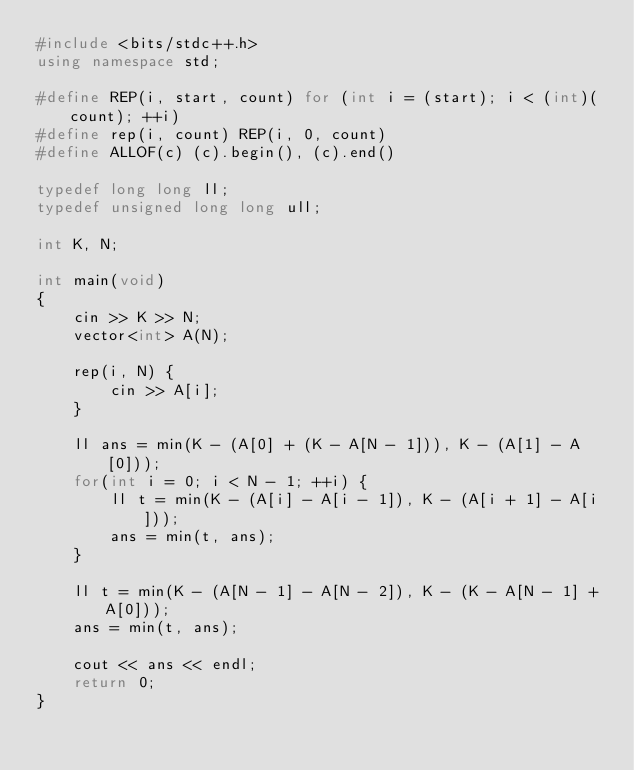<code> <loc_0><loc_0><loc_500><loc_500><_C++_>#include <bits/stdc++.h>
using namespace std;

#define REP(i, start, count) for (int i = (start); i < (int)(count); ++i)
#define rep(i, count) REP(i, 0, count)
#define ALLOF(c) (c).begin(), (c).end()

typedef long long ll;
typedef unsigned long long ull;

int K, N;

int main(void)
{
    cin >> K >> N;
    vector<int> A(N);

    rep(i, N) {
        cin >> A[i];
    }

    ll ans = min(K - (A[0] + (K - A[N - 1])), K - (A[1] - A[0]));
    for(int i = 0; i < N - 1; ++i) {
        ll t = min(K - (A[i] - A[i - 1]), K - (A[i + 1] - A[i]));
        ans = min(t, ans);
    }

    ll t = min(K - (A[N - 1] - A[N - 2]), K - (K - A[N - 1] + A[0]));
    ans = min(t, ans);

    cout << ans << endl;
    return 0;
}</code> 